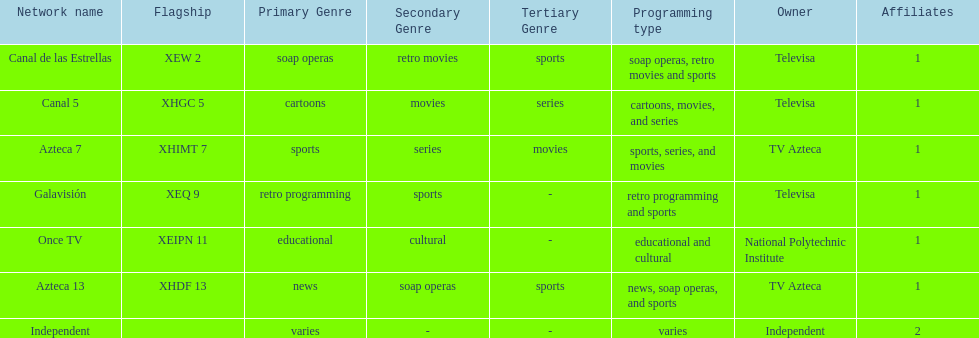What is the average number of affiliates that a given network will have? 1. 